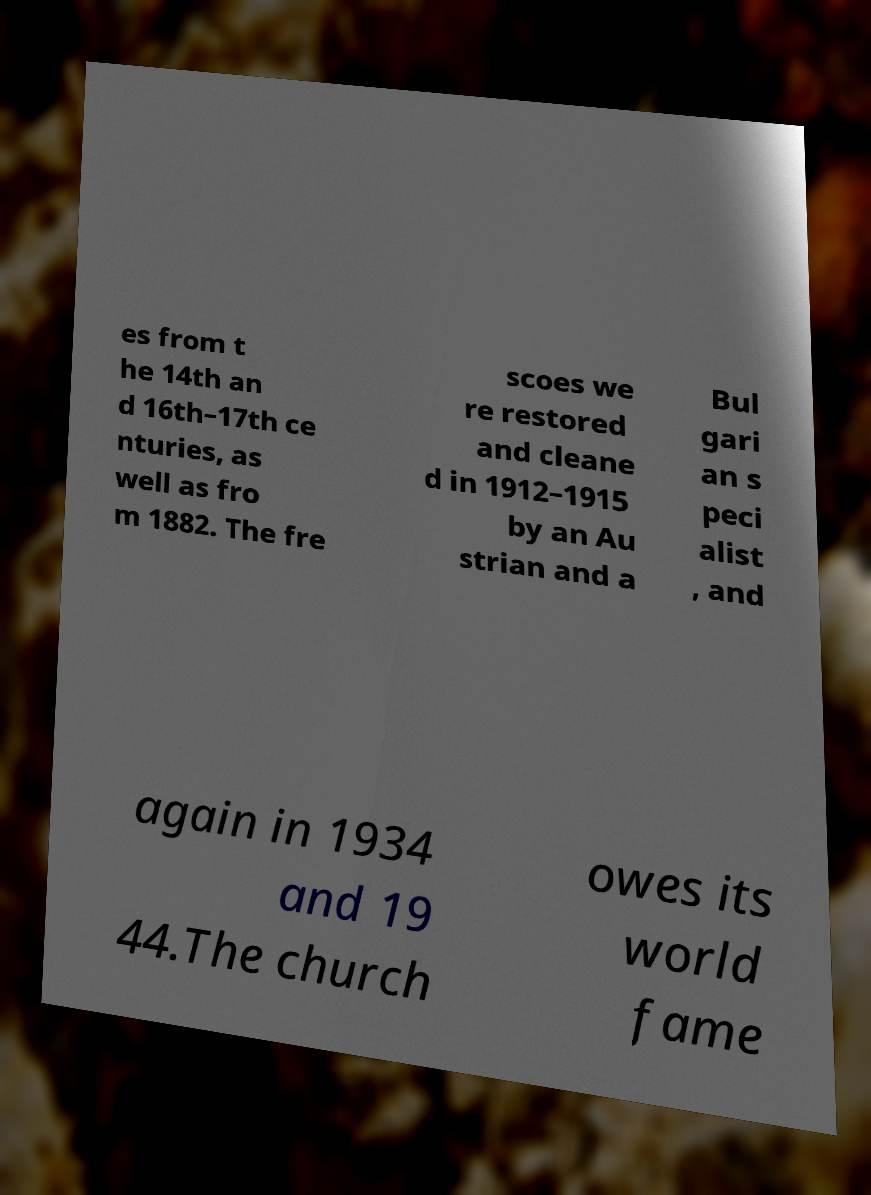Could you extract and type out the text from this image? es from t he 14th an d 16th–17th ce nturies, as well as fro m 1882. The fre scoes we re restored and cleane d in 1912–1915 by an Au strian and a Bul gari an s peci alist , and again in 1934 and 19 44.The church owes its world fame 